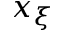<formula> <loc_0><loc_0><loc_500><loc_500>x _ { \xi }</formula> 